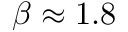<formula> <loc_0><loc_0><loc_500><loc_500>\beta \approx 1 . 8</formula> 